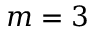<formula> <loc_0><loc_0><loc_500><loc_500>m = 3</formula> 